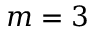<formula> <loc_0><loc_0><loc_500><loc_500>m = 3</formula> 